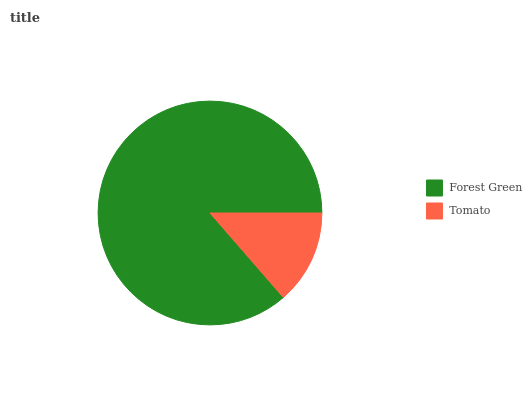Is Tomato the minimum?
Answer yes or no. Yes. Is Forest Green the maximum?
Answer yes or no. Yes. Is Tomato the maximum?
Answer yes or no. No. Is Forest Green greater than Tomato?
Answer yes or no. Yes. Is Tomato less than Forest Green?
Answer yes or no. Yes. Is Tomato greater than Forest Green?
Answer yes or no. No. Is Forest Green less than Tomato?
Answer yes or no. No. Is Forest Green the high median?
Answer yes or no. Yes. Is Tomato the low median?
Answer yes or no. Yes. Is Tomato the high median?
Answer yes or no. No. Is Forest Green the low median?
Answer yes or no. No. 